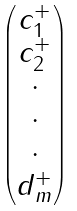<formula> <loc_0><loc_0><loc_500><loc_500>\begin{pmatrix} c _ { 1 } ^ { + } \\ c _ { 2 } ^ { + } \\ \cdot \\ \cdot \\ \cdot \\ d _ { m } ^ { + } \end{pmatrix}</formula> 